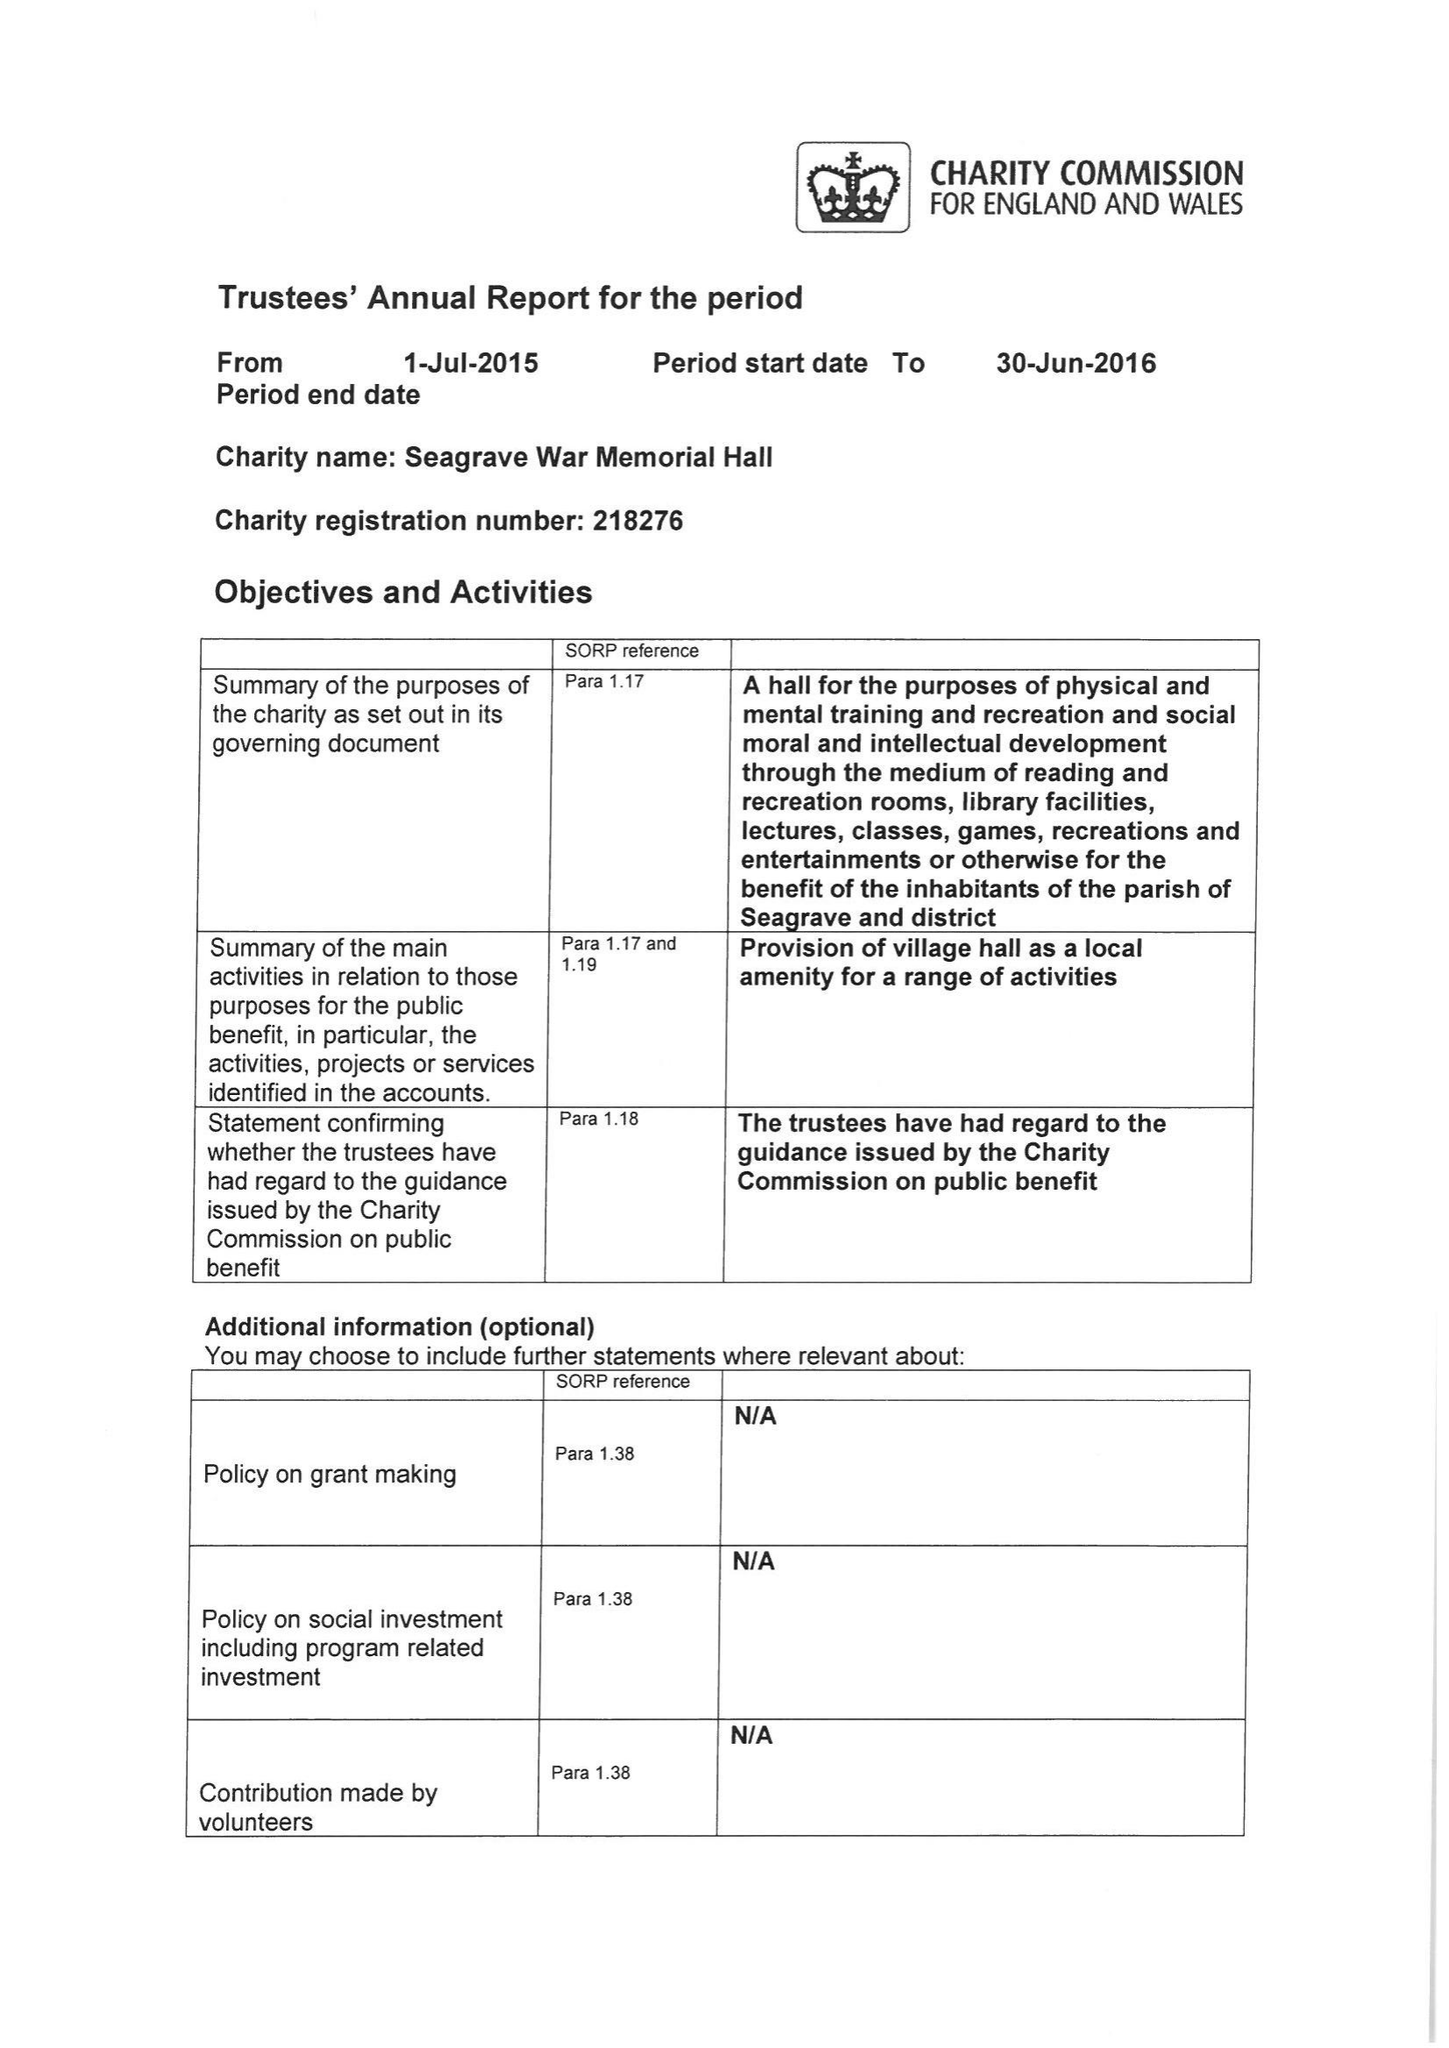What is the value for the address__post_town?
Answer the question using a single word or phrase. LOUGHBOROUGH 